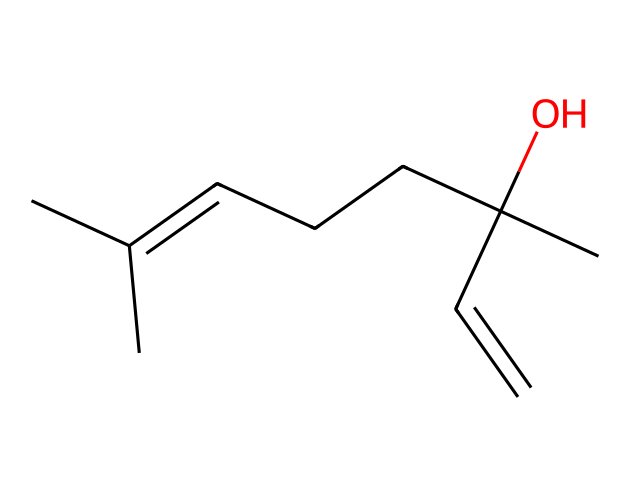What is the molecular formula of the compound represented by the SMILES? By interpreting the SMILES notation, we count the number of carbon (C), hydrogen (H), and oxygen (O) atoms. The structure has 10 carbon atoms, 16 hydrogen atoms, and 1 oxygen atom, which gives us the molecular formula C10H16O.
Answer: C10H16O How many double bonds are present in the chemical structure? Analyzing the SMILES reveals that there is one double bond indicated by the notation "C=C", meaning there is one carbon-carbon double bond in the structure.
Answer: 1 What functional group is indicated by the "(O)" in the SMILES? The presence of "(O)" indicates a hydroxyl group, which is a characteristic functional group in alcohols. The hydroxyl group (–OH) is associated with properties like increased polarity and solubility in water.
Answer: hydroxyl group Is the compound a saturated or unsaturated hydrocarbon? Since unsaturation is indicated by the presence of a double bond, we conclude that the presence of a "C=C" bond makes this compound unsaturated. Saturated hydrocarbons do not contain double or triple bonds.
Answer: unsaturated What type of isomerism can occur in this chemical compound? Given that this compound has a double bond, it can exhibit geometric (cis-trans) isomerism, which arises from the restricted rotation around the double bond. This means the arrangement of substituents can vary, leading to different isomers.
Answer: geometric isomerism 